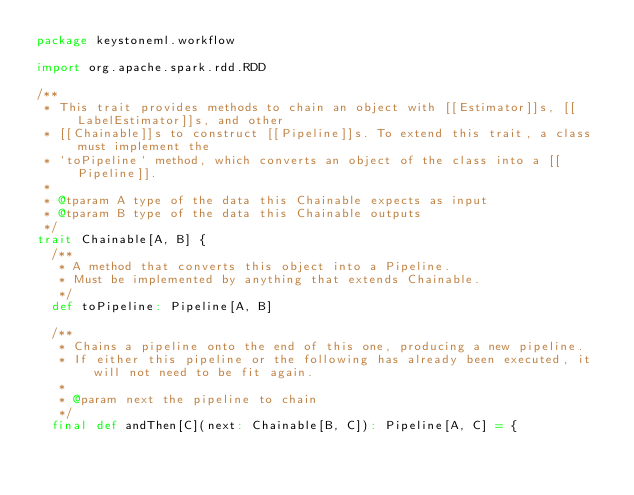<code> <loc_0><loc_0><loc_500><loc_500><_Scala_>package keystoneml.workflow

import org.apache.spark.rdd.RDD

/**
 * This trait provides methods to chain an object with [[Estimator]]s, [[LabelEstimator]]s, and other
 * [[Chainable]]s to construct [[Pipeline]]s. To extend this trait, a class must implement the
 * `toPipeline` method, which converts an object of the class into a [[Pipeline]].
 *
 * @tparam A type of the data this Chainable expects as input
 * @tparam B type of the data this Chainable outputs
 */
trait Chainable[A, B] {
  /**
   * A method that converts this object into a Pipeline.
   * Must be implemented by anything that extends Chainable.
   */
  def toPipeline: Pipeline[A, B]

  /**
   * Chains a pipeline onto the end of this one, producing a new pipeline.
   * If either this pipeline or the following has already been executed, it will not need to be fit again.
   *
   * @param next the pipeline to chain
   */
  final def andThen[C](next: Chainable[B, C]): Pipeline[A, C] = {</code> 